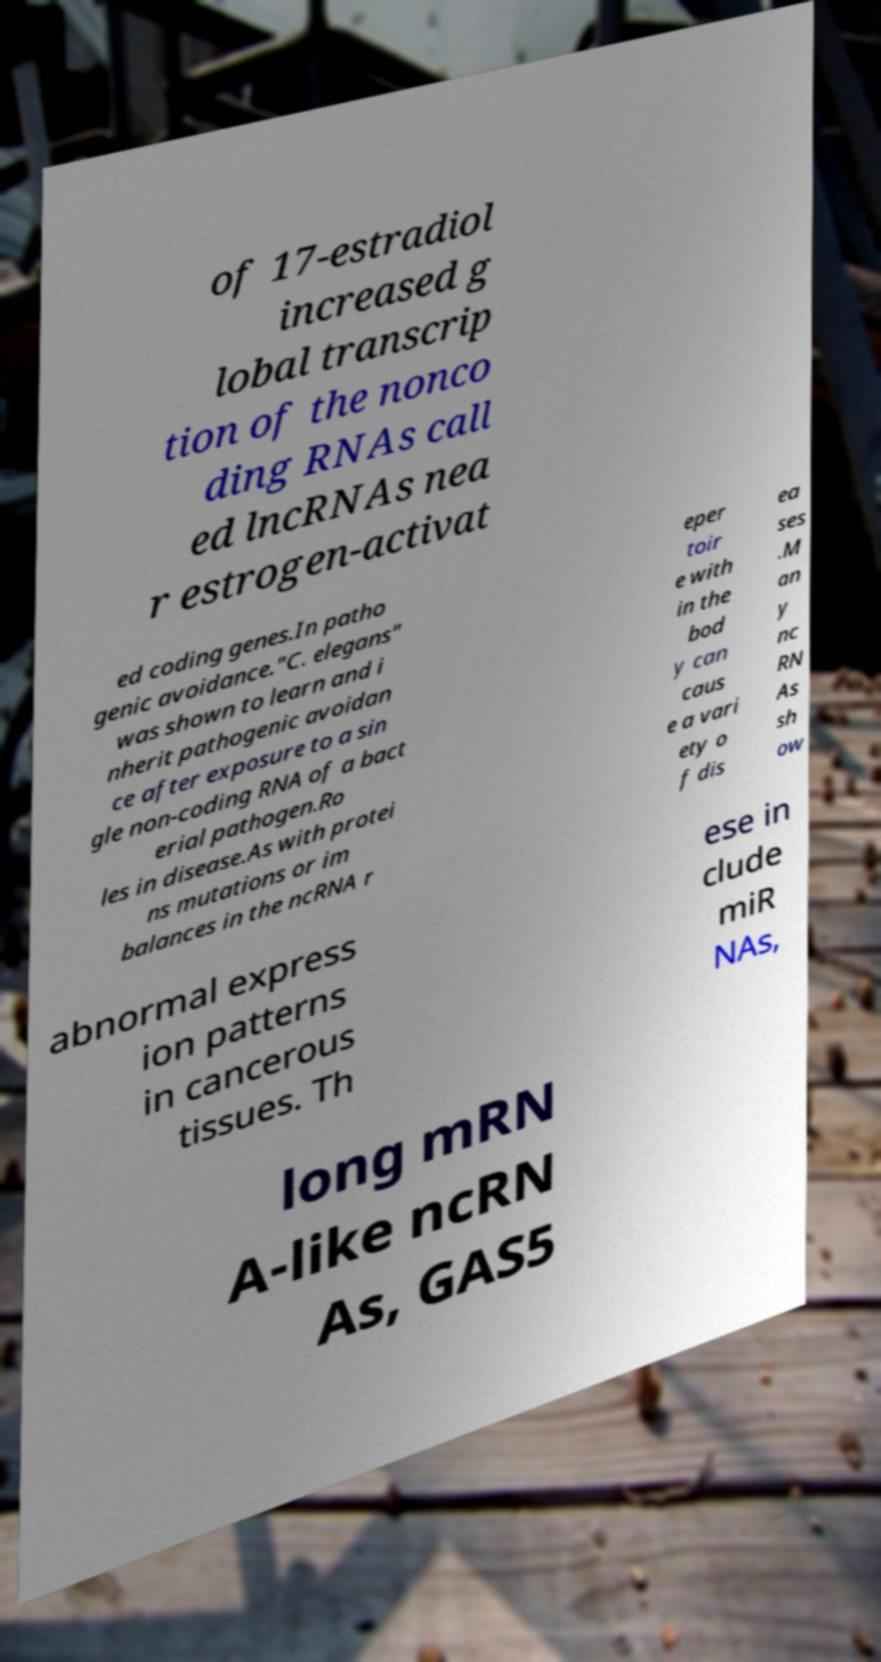Can you accurately transcribe the text from the provided image for me? of 17-estradiol increased g lobal transcrip tion of the nonco ding RNAs call ed lncRNAs nea r estrogen-activat ed coding genes.In patho genic avoidance."C. elegans" was shown to learn and i nherit pathogenic avoidan ce after exposure to a sin gle non-coding RNA of a bact erial pathogen.Ro les in disease.As with protei ns mutations or im balances in the ncRNA r eper toir e with in the bod y can caus e a vari ety o f dis ea ses .M an y nc RN As sh ow abnormal express ion patterns in cancerous tissues. Th ese in clude miR NAs, long mRN A-like ncRN As, GAS5 